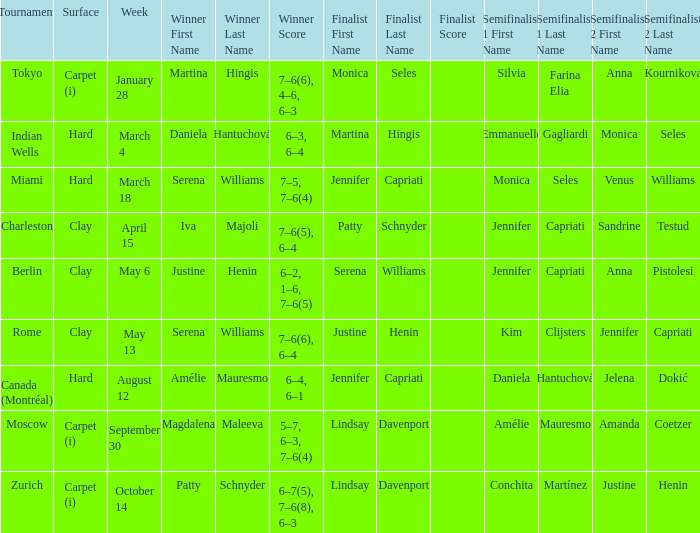What was the surface for finalist Justine Henin? Clay. 